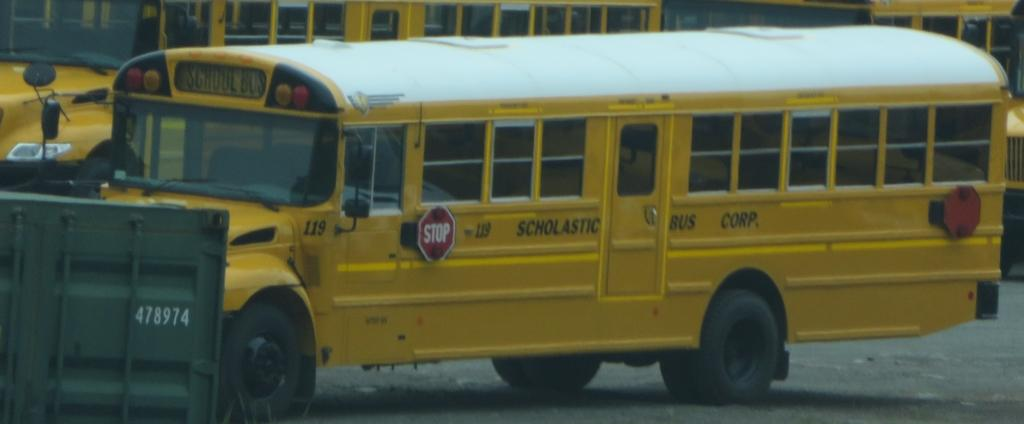<image>
Give a short and clear explanation of the subsequent image. the word scholastic is on the yellow school bus 